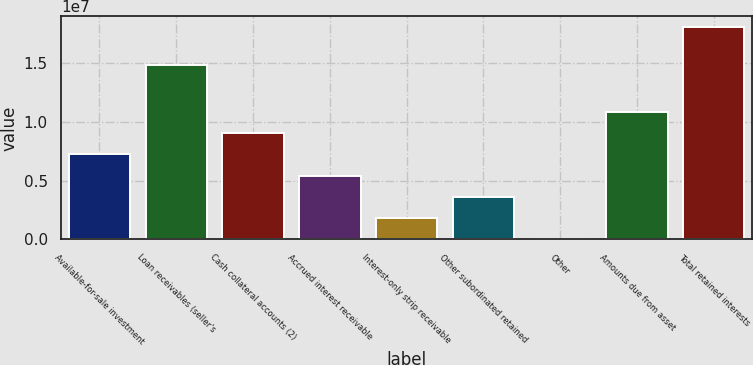<chart> <loc_0><loc_0><loc_500><loc_500><bar_chart><fcel>Available-for-sale investment<fcel>Loan receivables (seller's<fcel>Cash collateral accounts (2)<fcel>Accrued interest receivable<fcel>Interest-only strip receivable<fcel>Other subordinated retained<fcel>Other<fcel>Amounts due from asset<fcel>Total retained interests<nl><fcel>7.23242e+06<fcel>1.48319e+07<fcel>9.0349e+06<fcel>5.42995e+06<fcel>1.82499e+06<fcel>3.62747e+06<fcel>22516<fcel>1.08374e+07<fcel>1.80473e+07<nl></chart> 